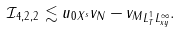<formula> <loc_0><loc_0><loc_500><loc_500>\mathcal { I } _ { 4 , 2 , 2 } \lesssim \| u _ { 0 } \| _ { X ^ { s } } \| v _ { N } - v _ { M } \| _ { L ^ { 1 } _ { T } L ^ { \infty } _ { x y } } .</formula> 